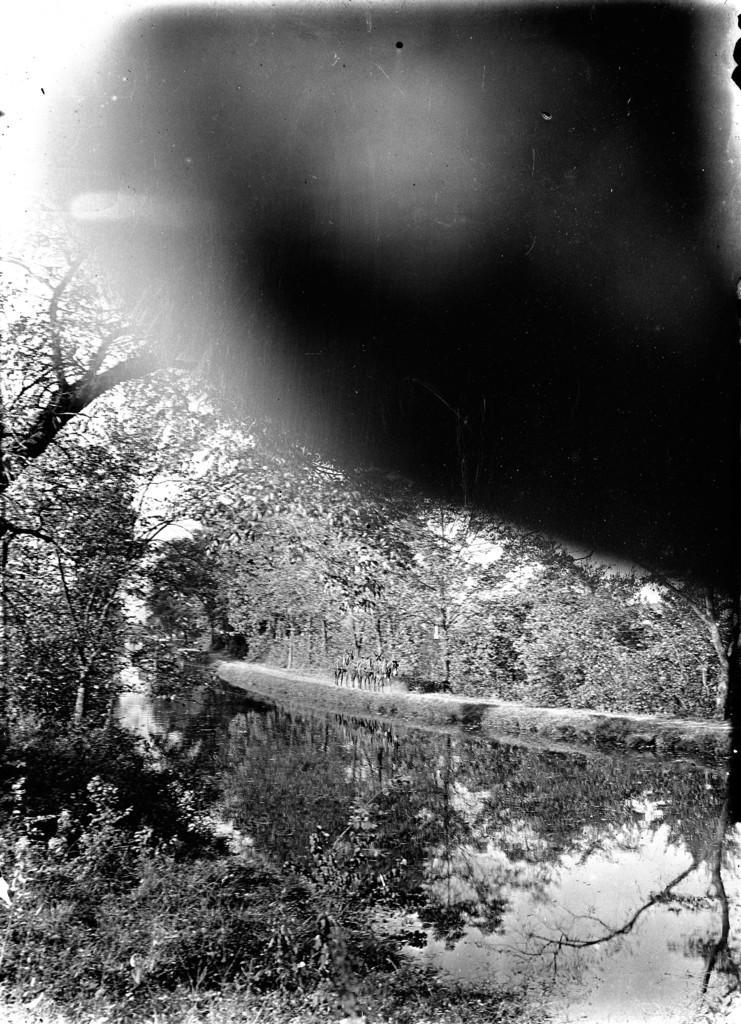Please provide a concise description of this image. In this picture I can see few trees and I can see a black color thing on the top right side of this picture and I see that this is a black and white picture. 